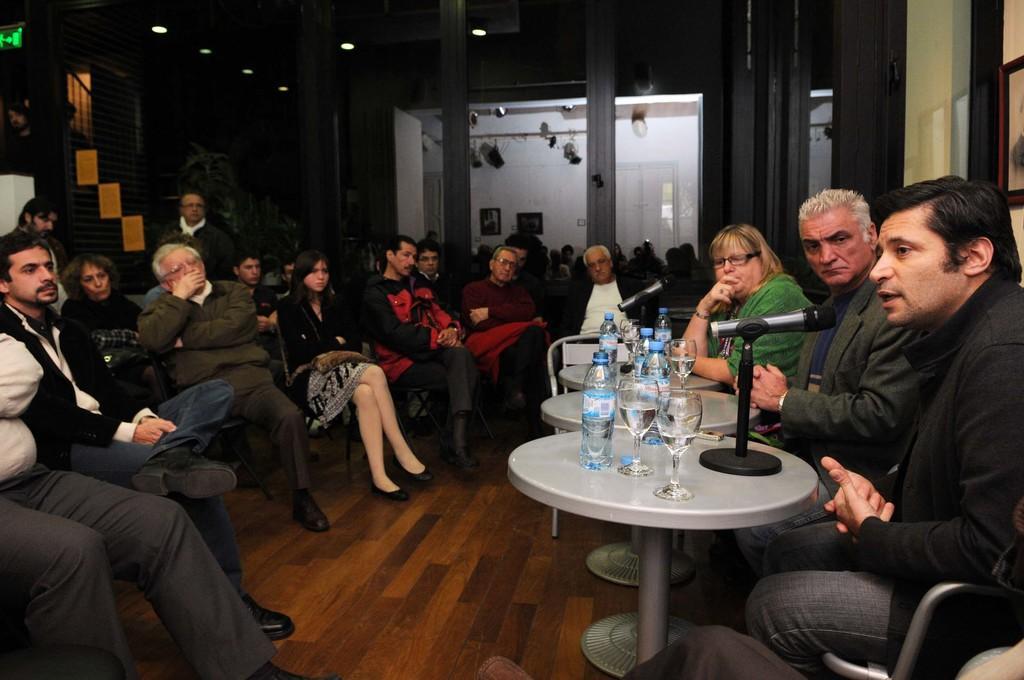Could you give a brief overview of what you see in this image? people are sitting on the chairs. on the right there are tables on which there are bottles, glasses and microphone. behind that there are glass doors. 